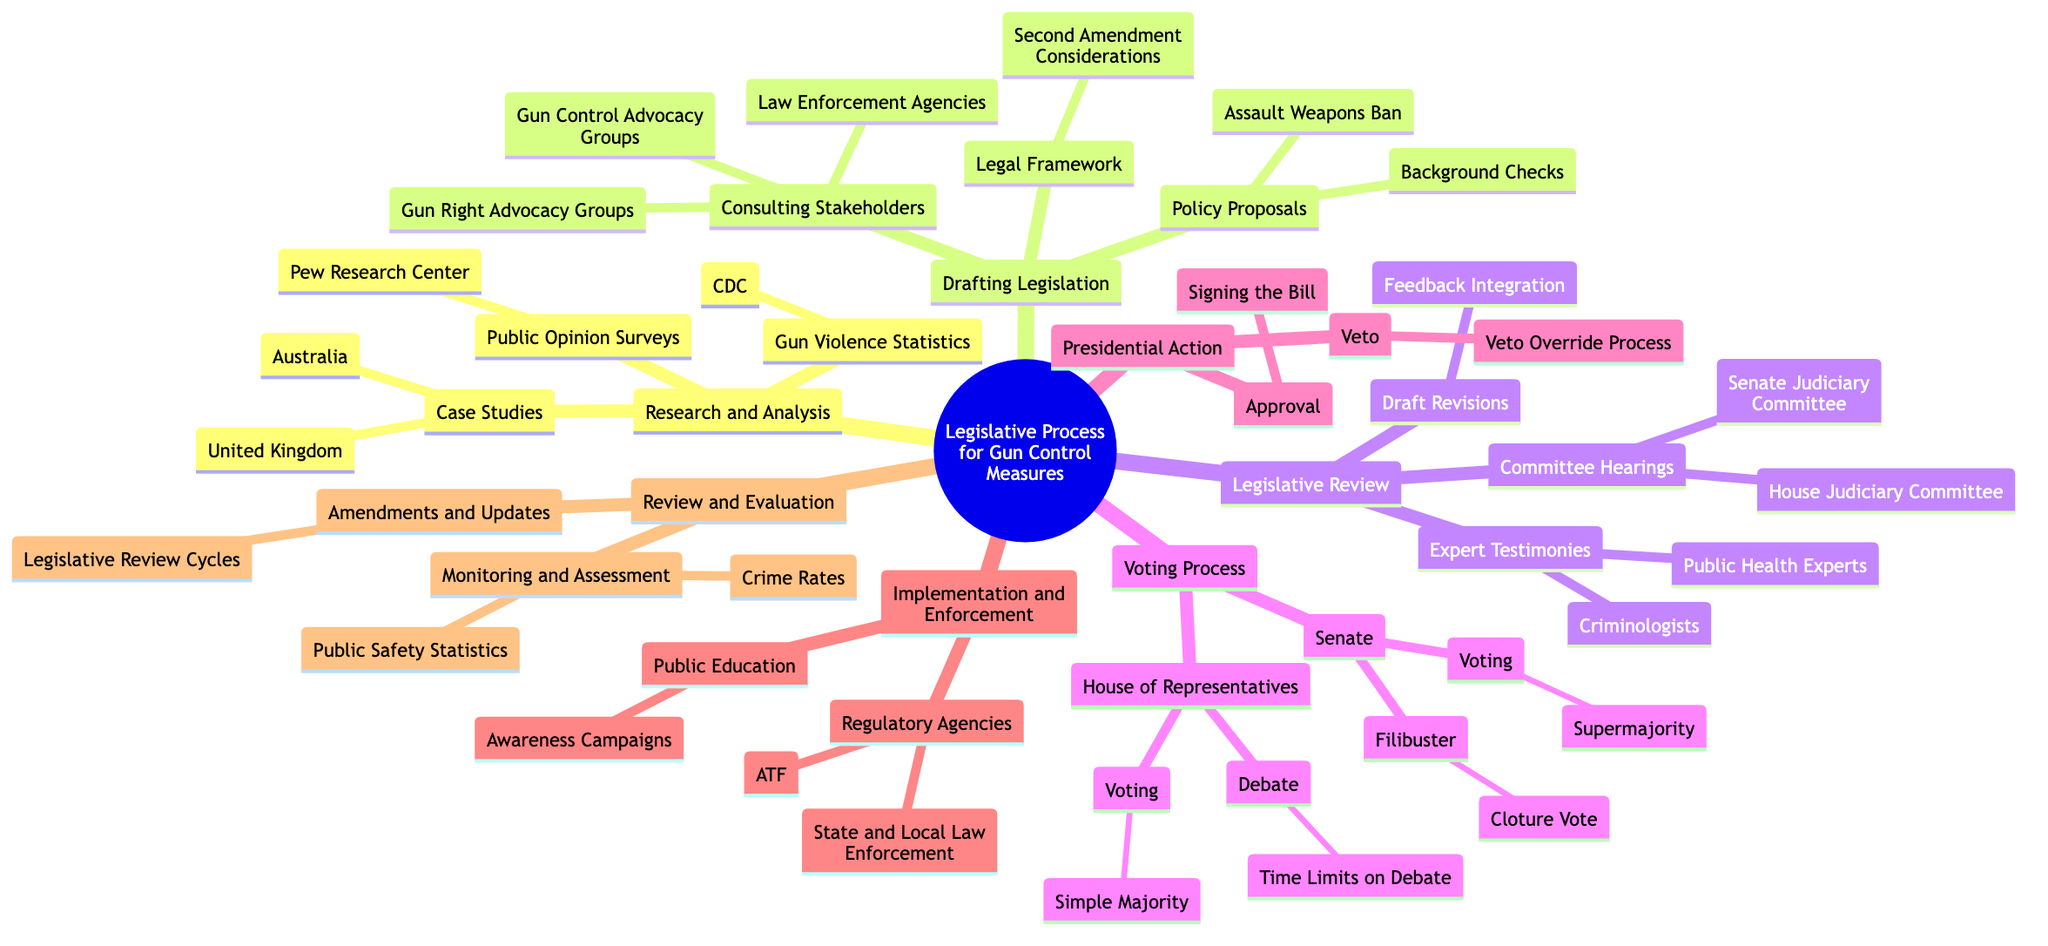What are two case studies mentioned in the diagram? The diagram lists "Australia" and "United Kingdom" under the "Case Studies" node of "Research and Analysis".
Answer: Australia, United Kingdom Which committee is responsible for legislative review in the House? The diagram specifies "House Judiciary Committee" as one of the committee hearings under the "Legislative Review" section.
Answer: House Judiciary Committee What type of proposal is explicitly stated in the "Drafting Legislation" section? The "Policy Proposals" node includes "Background Checks" and "Assault Weapons Ban". For this question, either phrase could be valid.
Answer: Background Checks How many regulatory agencies are listed under "Implementation and Enforcement"? The diagram indicates two regulatory agencies: "Bureau of Alcohol, Tobacco, Firearms and Explosives (ATF)" and "State and Local Law Enforcement".
Answer: 2 What is required for voting in the Senate as shown in the diagram? The diagram states that "Voting" in the Senate requires a "Supermajority", which refers to more than a simple majority.
Answer: Supermajority What is the purpose of "Awareness Campaigns"? The "Public Education" node under "Implementation and Enforcement" mentions "Awareness Campaigns" as the initiative to educate the public.
Answer: Awareness Campaigns What type of experts might provide testimonies during the legislative review? The diagram identifies "Criminologists" and "Public Health Experts" as the types of experts providing testimonies in the "Expert Testimonies" node under "Legislative Review".
Answer: Criminologists, Public Health Experts What are the two actions a President can take on a bill? The "Presidential Action" section includes "Signing the Bill" and "Veto" as two actions that can be taken by the President.
Answer: Signing the Bill, Veto 